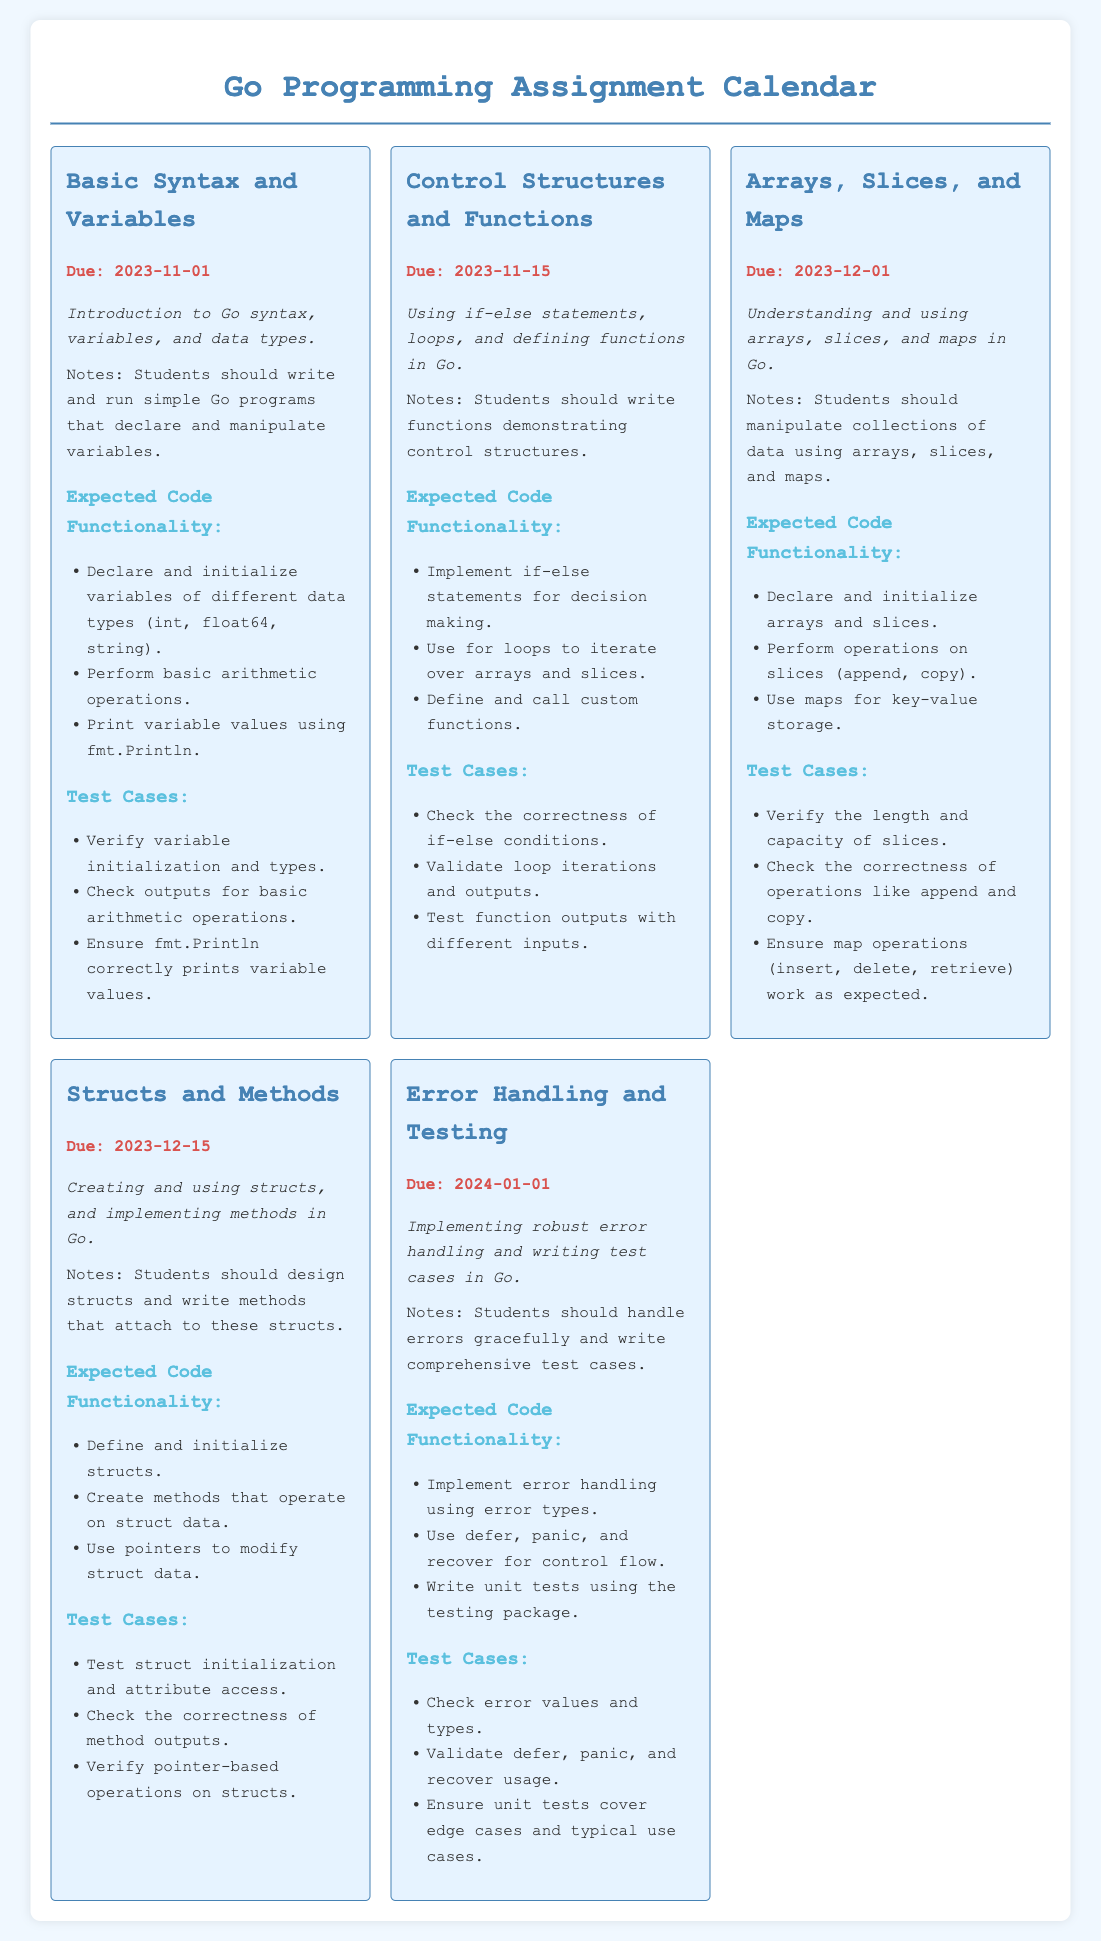What is the title of the document? The title is specified in the <title> tag of the document, which indicates the subject matter covered.
Answer: Go Programming Assignment Calendar What is the due date for the assignment on Control Structures and Functions? The due date for this assignment is noted clearly under its title.
Answer: 2023-11-15 Which assignment has the latest due date? The assignment with the latest due date is identified by comparing all assigned due dates listed in the document.
Answer: Error Handling and Testing What is the expected code functionality for the assignment on Arrays, Slices, and Maps? The expected code functionality outlines what students should be able to do for this assignment and is detailed under its specific section.
Answer: Declare and initialize arrays and slices What type of functionality should be implemented for the assignment on Structs and Methods? This question asks about the fundamental requirements that students need to meet for this assignment, as outlined in the document.
Answer: Define and initialize structs How many test cases are listed for the Error Handling and Testing assignment? The number of test cases is specified in the relevant section of the assignment information within the document.
Answer: Three What is one key operation that should be validated for the Arrays, Slices, and Maps assignment? This identifies a specific expected action that should be a focus of testing, as detailed in the document.
Answer: Append What type of error handling is emphasized in the Error Handling and Testing assignment? The document outlines specific techniques that need to be utilized in error handling, which is detailed under the relevant assignment section.
Answer: Error types What is the minimum number of assignments due in November? This question requires counting the number of assignments with due dates in November indicated in the document.
Answer: Two 